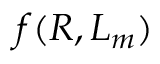<formula> <loc_0><loc_0><loc_500><loc_500>f ( R , L _ { m } )</formula> 